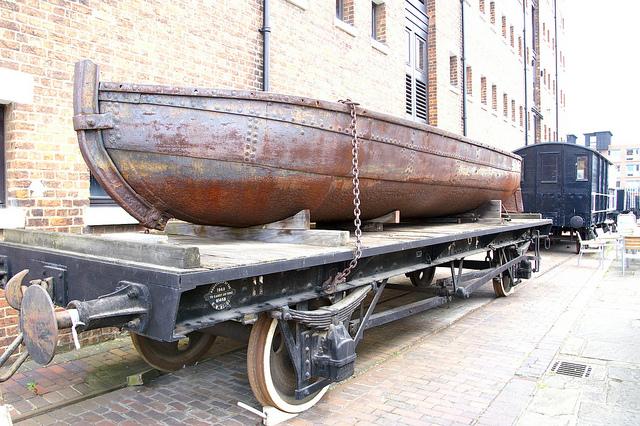What color is the train?
Quick response, please. Black. What kind of vehicle is this?
Answer briefly. Boat. What is the stuff on the bottom of this boat?
Answer briefly. Rust. 